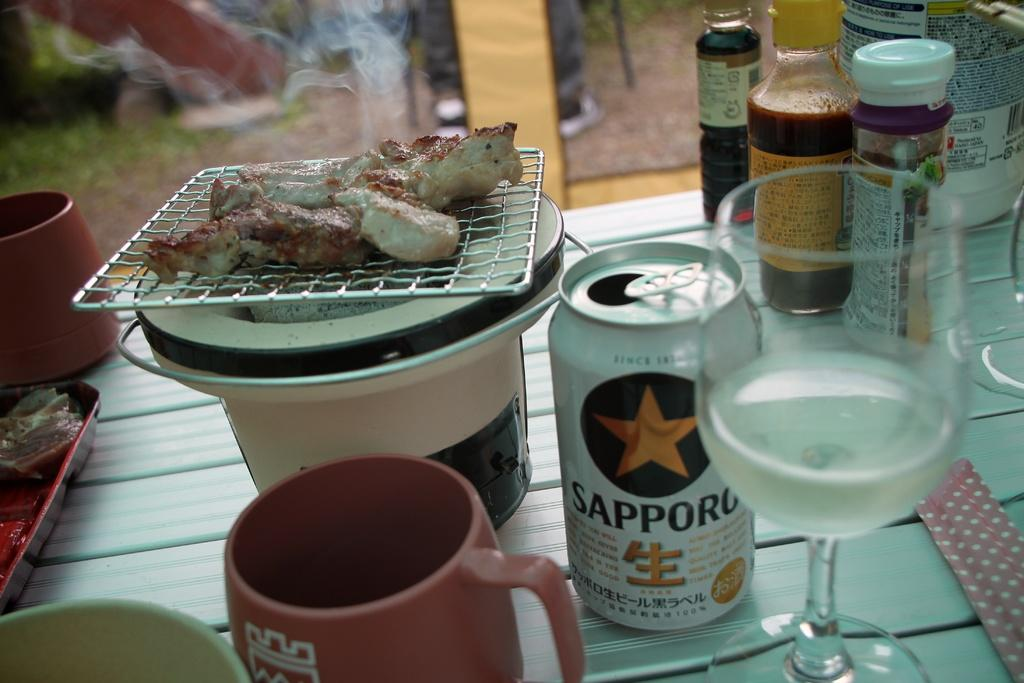<image>
Describe the image concisely. A Sapporg can of beer is on a table next to a drinking glass. 